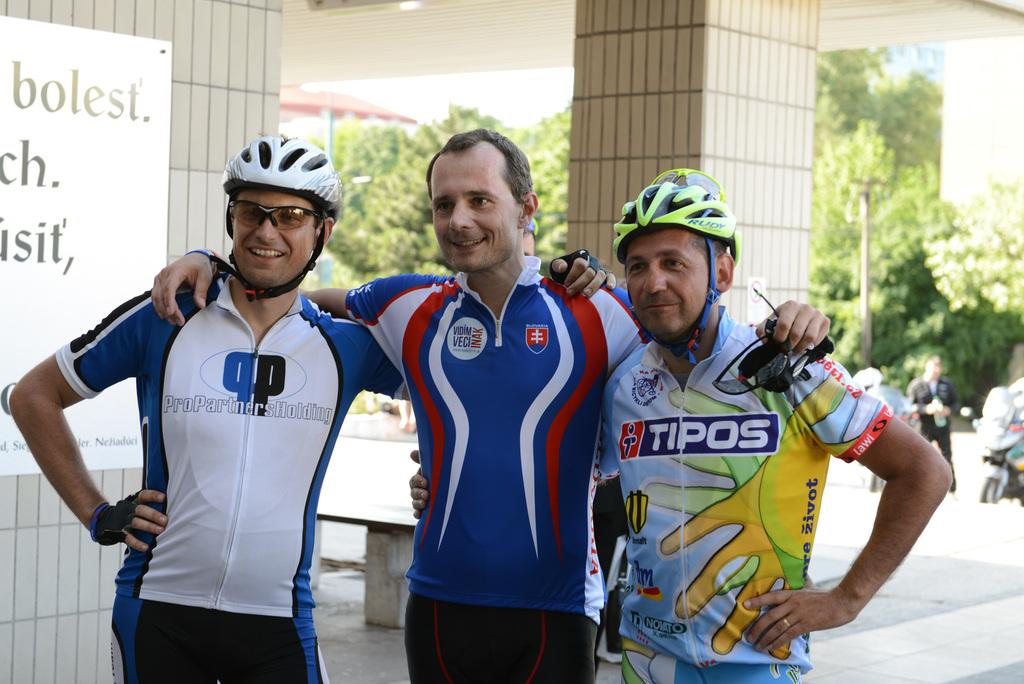<image>
Create a compact narrative representing the image presented. a biker with a helmet and Tipos on his shirt 